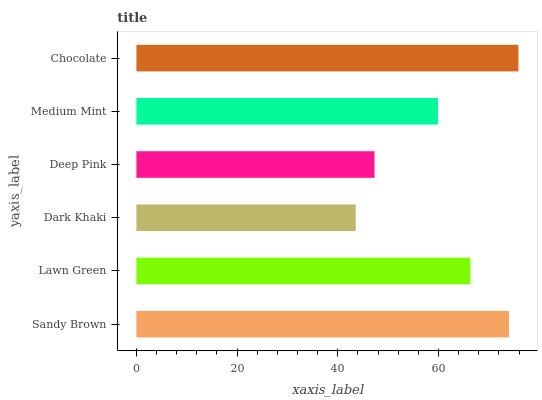Is Dark Khaki the minimum?
Answer yes or no. Yes. Is Chocolate the maximum?
Answer yes or no. Yes. Is Lawn Green the minimum?
Answer yes or no. No. Is Lawn Green the maximum?
Answer yes or no. No. Is Sandy Brown greater than Lawn Green?
Answer yes or no. Yes. Is Lawn Green less than Sandy Brown?
Answer yes or no. Yes. Is Lawn Green greater than Sandy Brown?
Answer yes or no. No. Is Sandy Brown less than Lawn Green?
Answer yes or no. No. Is Lawn Green the high median?
Answer yes or no. Yes. Is Medium Mint the low median?
Answer yes or no. Yes. Is Dark Khaki the high median?
Answer yes or no. No. Is Deep Pink the low median?
Answer yes or no. No. 